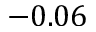Convert formula to latex. <formula><loc_0><loc_0><loc_500><loc_500>- 0 . 0 6</formula> 